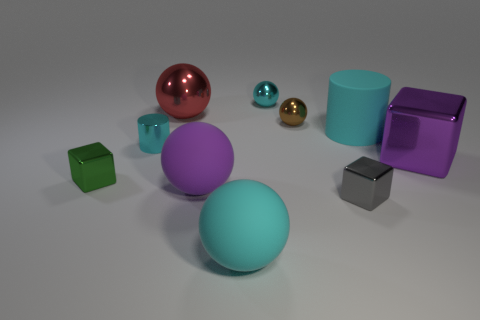What size is the red metallic object that is the same shape as the big purple matte thing?
Offer a terse response. Large. Is the number of big red objects to the left of the cyan matte cylinder greater than the number of tiny gray metal things right of the purple metallic cube?
Your answer should be compact. Yes. There is a thing that is right of the purple sphere and behind the tiny brown thing; what material is it?
Offer a very short reply. Metal. What is the color of the other tiny thing that is the same shape as the brown metallic thing?
Your answer should be very brief. Cyan. How big is the purple shiny thing?
Give a very brief answer. Large. There is a cylinder that is on the right side of the cyan sphere behind the big purple metal cube; what color is it?
Your response must be concise. Cyan. How many shiny things are both right of the purple matte thing and behind the big purple block?
Your answer should be very brief. 2. Is the number of large cyan objects greater than the number of small brown rubber cubes?
Provide a succinct answer. Yes. What is the big purple block made of?
Provide a succinct answer. Metal. How many shiny objects are right of the big cyan rubber thing that is in front of the purple rubber thing?
Give a very brief answer. 4. 